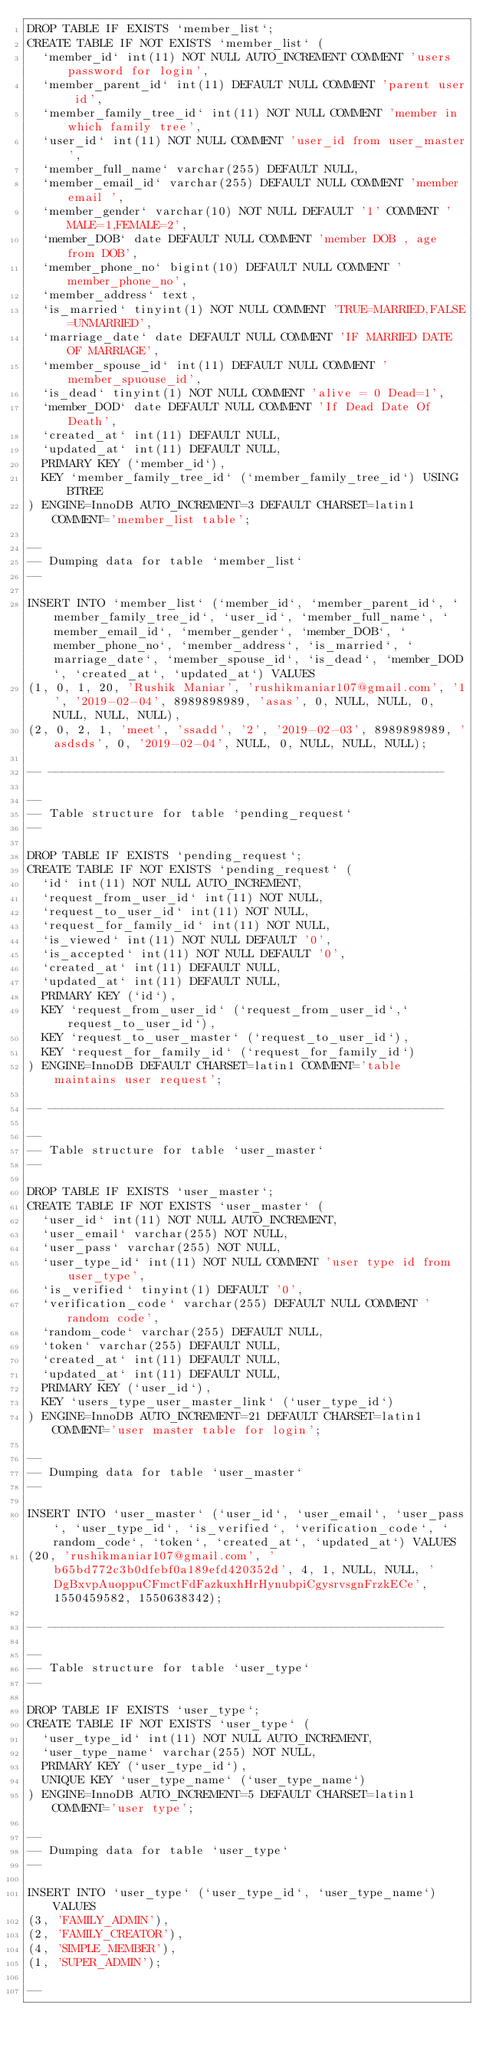Convert code to text. <code><loc_0><loc_0><loc_500><loc_500><_SQL_>DROP TABLE IF EXISTS `member_list`;
CREATE TABLE IF NOT EXISTS `member_list` (
  `member_id` int(11) NOT NULL AUTO_INCREMENT COMMENT 'users password for login',
  `member_parent_id` int(11) DEFAULT NULL COMMENT 'parent user id',
  `member_family_tree_id` int(11) NOT NULL COMMENT 'member in which family tree',
  `user_id` int(11) NOT NULL COMMENT 'user_id from user_master',
  `member_full_name` varchar(255) DEFAULT NULL,
  `member_email_id` varchar(255) DEFAULT NULL COMMENT 'member email ',
  `member_gender` varchar(10) NOT NULL DEFAULT '1' COMMENT 'MALE=1,FEMALE=2',
  `member_DOB` date DEFAULT NULL COMMENT 'member DOB , age from DOB',
  `member_phone_no` bigint(10) DEFAULT NULL COMMENT 'member_phone_no',
  `member_address` text,
  `is_married` tinyint(1) NOT NULL COMMENT 'TRUE=MARRIED,FALSE=UNMARRIED',
  `marriage_date` date DEFAULT NULL COMMENT 'IF MARRIED DATE OF MARRIAGE',
  `member_spouse_id` int(11) DEFAULT NULL COMMENT 'member_spuouse_id',
  `is_dead` tinyint(1) NOT NULL COMMENT 'alive = 0 Dead=1',
  `member_DOD` date DEFAULT NULL COMMENT 'If Dead Date Of Death',
  `created_at` int(11) DEFAULT NULL,
  `updated_at` int(11) DEFAULT NULL,
  PRIMARY KEY (`member_id`),
  KEY `member_family_tree_id` (`member_family_tree_id`) USING BTREE
) ENGINE=InnoDB AUTO_INCREMENT=3 DEFAULT CHARSET=latin1 COMMENT='member_list table';

--
-- Dumping data for table `member_list`
--

INSERT INTO `member_list` (`member_id`, `member_parent_id`, `member_family_tree_id`, `user_id`, `member_full_name`, `member_email_id`, `member_gender`, `member_DOB`, `member_phone_no`, `member_address`, `is_married`, `marriage_date`, `member_spouse_id`, `is_dead`, `member_DOD`, `created_at`, `updated_at`) VALUES
(1, 0, 1, 20, 'Rushik Maniar', 'rushikmaniar107@gmail.com', '1', '2019-02-04', 8989898989, 'asas', 0, NULL, NULL, 0, NULL, NULL, NULL),
(2, 0, 2, 1, 'meet', 'ssadd', '2', '2019-02-03', 8989898989, 'asdsds', 0, '2019-02-04', NULL, 0, NULL, NULL, NULL);

-- --------------------------------------------------------

--
-- Table structure for table `pending_request`
--

DROP TABLE IF EXISTS `pending_request`;
CREATE TABLE IF NOT EXISTS `pending_request` (
  `id` int(11) NOT NULL AUTO_INCREMENT,
  `request_from_user_id` int(11) NOT NULL,
  `request_to_user_id` int(11) NOT NULL,
  `request_for_family_id` int(11) NOT NULL,
  `is_viewed` int(11) NOT NULL DEFAULT '0',
  `is_accepted` int(11) NOT NULL DEFAULT '0',
  `created_at` int(11) DEFAULT NULL,
  `updated_at` int(11) DEFAULT NULL,
  PRIMARY KEY (`id`),
  KEY `request_from_user_id` (`request_from_user_id`,`request_to_user_id`),
  KEY `request_to_user_master` (`request_to_user_id`),
  KEY `request_for_family_id` (`request_for_family_id`)
) ENGINE=InnoDB DEFAULT CHARSET=latin1 COMMENT='table maintains user request';

-- --------------------------------------------------------

--
-- Table structure for table `user_master`
--

DROP TABLE IF EXISTS `user_master`;
CREATE TABLE IF NOT EXISTS `user_master` (
  `user_id` int(11) NOT NULL AUTO_INCREMENT,
  `user_email` varchar(255) NOT NULL,
  `user_pass` varchar(255) NOT NULL,
  `user_type_id` int(11) NOT NULL COMMENT 'user type id from user_type',
  `is_verified` tinyint(1) DEFAULT '0',
  `verification_code` varchar(255) DEFAULT NULL COMMENT 'random code',
  `random_code` varchar(255) DEFAULT NULL,
  `token` varchar(255) DEFAULT NULL,
  `created_at` int(11) DEFAULT NULL,
  `updated_at` int(11) DEFAULT NULL,
  PRIMARY KEY (`user_id`),
  KEY `users_type_user_master_link` (`user_type_id`)
) ENGINE=InnoDB AUTO_INCREMENT=21 DEFAULT CHARSET=latin1 COMMENT='user master table for login';

--
-- Dumping data for table `user_master`
--

INSERT INTO `user_master` (`user_id`, `user_email`, `user_pass`, `user_type_id`, `is_verified`, `verification_code`, `random_code`, `token`, `created_at`, `updated_at`) VALUES
(20, 'rushikmaniar107@gmail.com', 'b65bd772c3b0dfebf0a189efd420352d', 4, 1, NULL, NULL, 'DgBxvpAuoppuCFmctFdFazkuxhHrHynubpiCgysrvsgnFrzkECe', 1550459582, 1550638342);

-- --------------------------------------------------------

--
-- Table structure for table `user_type`
--

DROP TABLE IF EXISTS `user_type`;
CREATE TABLE IF NOT EXISTS `user_type` (
  `user_type_id` int(11) NOT NULL AUTO_INCREMENT,
  `user_type_name` varchar(255) NOT NULL,
  PRIMARY KEY (`user_type_id`),
  UNIQUE KEY `user_type_name` (`user_type_name`)
) ENGINE=InnoDB AUTO_INCREMENT=5 DEFAULT CHARSET=latin1 COMMENT='user type';

--
-- Dumping data for table `user_type`
--

INSERT INTO `user_type` (`user_type_id`, `user_type_name`) VALUES
(3, 'FAMILY_ADMIN'),
(2, 'FAMILY_CREATOR'),
(4, 'SIMPLE_MEMBER'),
(1, 'SUPER_ADMIN');

--</code> 